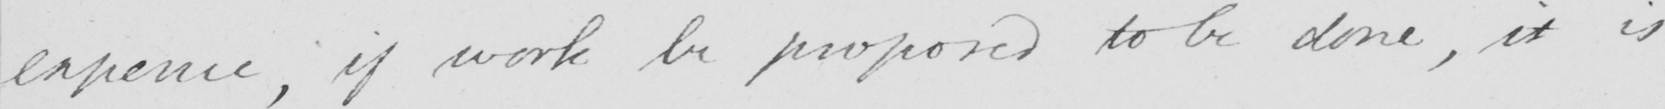What is written in this line of handwriting? expence if work be proposed to be done , it is 